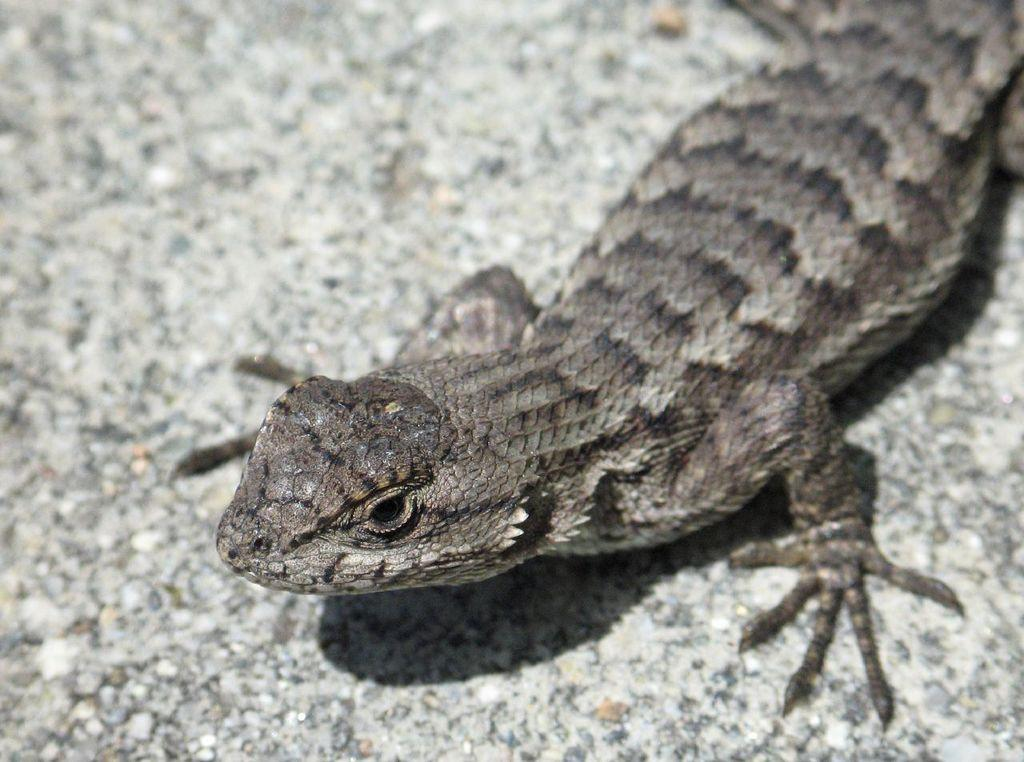What type of animal is present in the image? There is a lizard in the image. What type of yak can be seen in the image? There is no yak present in the image; it features a lizard. What type of police vehicle is visible in the image? There is no police vehicle present in the image; it features a lizard. 